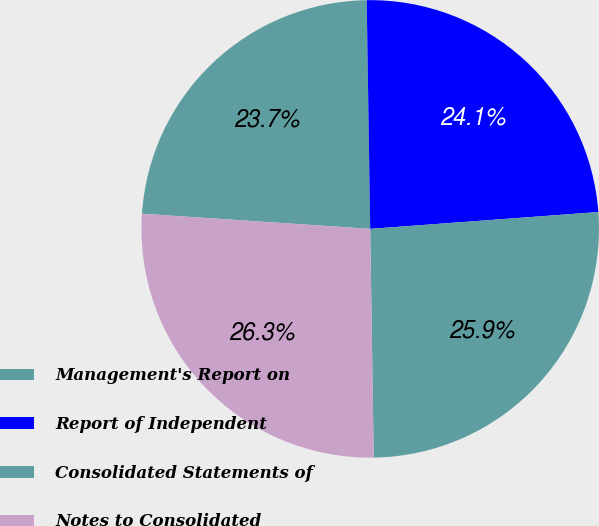<chart> <loc_0><loc_0><loc_500><loc_500><pie_chart><fcel>Management's Report on<fcel>Report of Independent<fcel>Consolidated Statements of<fcel>Notes to Consolidated<nl><fcel>23.7%<fcel>24.07%<fcel>25.93%<fcel>26.3%<nl></chart> 